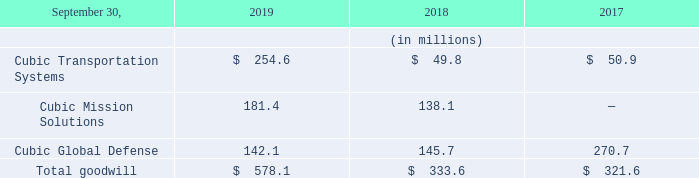Valuation of Goodwill
Goodwill balances by reporting unit are as follows:
Goodwill represents the purchase price paid in excess of the fair value of net tangible and intangible assets acquired. Goodwill is not amortized but is subject to an impairment test at a reporting unit level on an annual basis and when circumstances indicate that an impairment is more-likely-than-not. Such circumstances that might indicate an impairment is more-likely-than-not include a significant adverse change in the business climate for one of our reporting units or a decision to dispose of a reporting unit or a significant portion of a reporting unit. The test for goodwill impairment is a two-step process. The first step of the test is performed by comparing the fair value of each reporting unit to its carrying amount, including recorded goodwill. If the carrying amount of a reporting unit exceeds its fair value, the second step is performed to measure the amount of the impairment, if any, by comparing the implied fair value of goodwill to its carrying amount. Any resulting impairment would be recorded in the current period.
Determining the fair value of a reporting unit for purposes of the goodwill impairment test or for changes in our operating structure is judgmental in nature and involves the use of estimates and assumptions. These estimates and assumptions could have a significant impact on whether or not an impairment charge is recognized and also the magnitude of any such charge. Estimates of fair value are primarily determined using discounted cash flows and market multiples from publicly traded comparable companies. These approaches use significant estimates and assumptions including projected future cash flows, discount rate reflecting the inherent risk in future cash flows, perpetual growth rate and determination of appropriate market comparables.
We evaluate our reporting units when changes in our operating structure occur, and if necessary, reassign goodwill using a relative fair value allocation approach. As described in Note 18 to our Consolidated Financial Statements in Item 8 of this Form 10-K, beginning on October 1, 2017, we concluded that CMS became a separate operating segment. In conjunction with the changes to reporting units, we reassigned goodwill between CGD and CMS based on their relative fair values as of October 1, 2017. We estimated the fair value of CGD and CMS at October 1, 2017 based upon market multiples from publicly traded comparable companies in addition to discounted cash flows models for CMS and for a combination of CGD and CMS based on discrete financial forecasts developed by management for planning purposes. Cash flows beyond the discrete forecasts were estimated based on projected growth rates and financial ratios, influenced by an analysis of historical ratios and by calculating a terminal value at the end of the discrete financial forecasts. For the October 1, 2017 valuations, future cash flows were discounted to present value using a discount rate of 13% for our CMS reporting unit and 11% for the combination of our CGD and CMS reporting units.
For the first step of our fiscal 2019 annual impairment test, we estimated the fair value of CTS based upon market multiples from publicly traded comparable companies and for CGD and CMS, we estimated the fair value based upon a combination of market multiples from publicly traded comparable companies and discounted cash flow models. The discounted cash flows were based on discrete three-year financial forecasts developed by management for planning purposes. Cash flows beyond the discrete forecasts were estimated based on projected growth rates and financial ratios, influenced by an analysis of historical ratios and by calculating a terminal value at the end of the three-year forecasts. The future cash flows were discounted to present value using a discount rate of 15% for CGD and 12.5% for CMS. The results of our 2019 annual impairment test indicated that the estimated fair value for our CTS and CGD reporting units exceeded their carrying amounts by over 100%, while the estimated fair value of our CMS reporting unit exceeded its carrying amount by over 60%.
Unforeseen negative changes in future business or other market conditions for any of our reporting units including margin compression or loss of business, could cause recorded goodwill to be impaired in the future. Also, changes in estimates and assumptions we make in conducting our goodwill assessment could affect the estimated fair value of our reporting units and could result in a goodwill impairment charge in a future period.
What does goodwill represent? The purchase price paid in excess of the fair value of net tangible and intangible assets acquired. How are estimates of fair value primarily determined? Using discounted cash flows and market multiples from publicly traded comparable companies. Which reporting units are considered under the goodwill balances in the table? Cubic transportation systems, cubic mission solutions, cubic global defense. In which year was the goodwill balance for  Cubic Transportation Systems the lowest? 49.8<50.9<254.6
Answer: 2018. What is the change in the amount of total goodwill in 2019 from 2018?
Answer scale should be: million. 578.1-333.6
Answer: 244.5. What is the percentage change in the amount of total goodwill in 2019 from 2018?
Answer scale should be: percent. (578.1-333.6)/333.6
Answer: 73.29. 